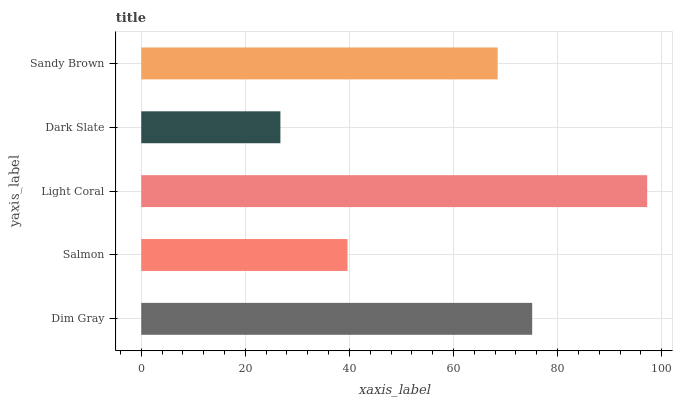Is Dark Slate the minimum?
Answer yes or no. Yes. Is Light Coral the maximum?
Answer yes or no. Yes. Is Salmon the minimum?
Answer yes or no. No. Is Salmon the maximum?
Answer yes or no. No. Is Dim Gray greater than Salmon?
Answer yes or no. Yes. Is Salmon less than Dim Gray?
Answer yes or no. Yes. Is Salmon greater than Dim Gray?
Answer yes or no. No. Is Dim Gray less than Salmon?
Answer yes or no. No. Is Sandy Brown the high median?
Answer yes or no. Yes. Is Sandy Brown the low median?
Answer yes or no. Yes. Is Salmon the high median?
Answer yes or no. No. Is Light Coral the low median?
Answer yes or no. No. 